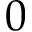Convert formula to latex. <formula><loc_0><loc_0><loc_500><loc_500>0</formula> 